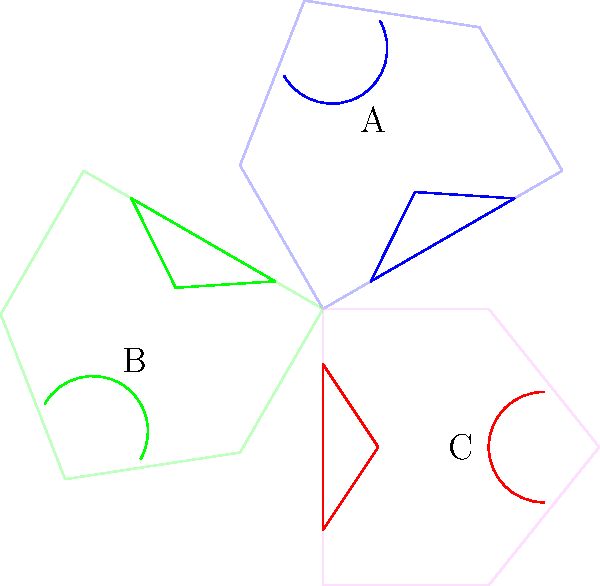As a seasoned politician, you're well-versed in recognizing iconic government structures. The image above shows three views of the same landmark building from different angles. Which view represents the perspective typically seen on the reverse side of a U.S. five-dollar bill? To answer this question, let's analyze each view:

1. View A (blue): This shows the building from an angle, with the dome visible on the right side. This is not the typical view on currency.

2. View B (green): This presents the building from the opposite angle of View A, with the dome on the left side. Again, this is not the standard view on U.S. currency.

3. View C (red): This depicts the building straight-on, with the dome centered and the steps clearly visible at the bottom. This is the classic view of the U.S. Capitol building as seen on the reverse of the five-dollar bill.

The U.S. five-dollar bill features the Lincoln Memorial on its back, but the question is asking about the Capitol building, which appears on other denominations. However, the principle of recognizing the straight-on view remains the same.

As a politician who frequently deals with matters of national importance, it's crucial to recognize this iconic view of the Capitol, which symbolizes the legislative branch of the U.S. government.
Answer: View C 